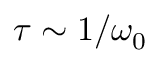Convert formula to latex. <formula><loc_0><loc_0><loc_500><loc_500>\tau \sim 1 / \omega _ { 0 }</formula> 